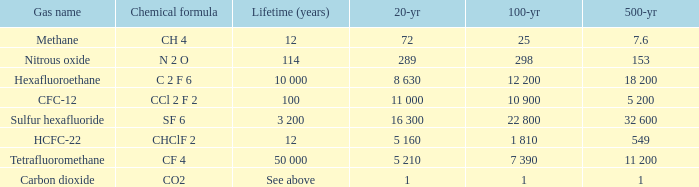What is the 20 year for Nitrous Oxide? 289.0. 